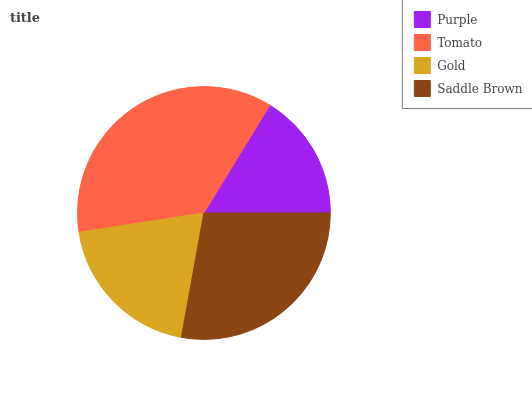Is Purple the minimum?
Answer yes or no. Yes. Is Tomato the maximum?
Answer yes or no. Yes. Is Gold the minimum?
Answer yes or no. No. Is Gold the maximum?
Answer yes or no. No. Is Tomato greater than Gold?
Answer yes or no. Yes. Is Gold less than Tomato?
Answer yes or no. Yes. Is Gold greater than Tomato?
Answer yes or no. No. Is Tomato less than Gold?
Answer yes or no. No. Is Saddle Brown the high median?
Answer yes or no. Yes. Is Gold the low median?
Answer yes or no. Yes. Is Tomato the high median?
Answer yes or no. No. Is Saddle Brown the low median?
Answer yes or no. No. 